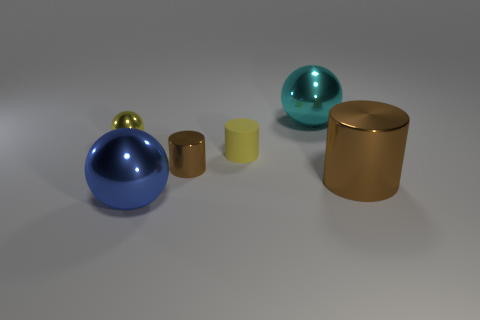Subtract all green blocks. How many brown cylinders are left? 2 Subtract all big shiny balls. How many balls are left? 1 Add 2 small yellow cubes. How many objects exist? 8 Subtract all gray spheres. Subtract all red blocks. How many spheres are left? 3 Add 2 tiny yellow shiny things. How many tiny yellow shiny things are left? 3 Add 3 big purple blocks. How many big purple blocks exist? 3 Subtract 0 gray balls. How many objects are left? 6 Subtract all blue rubber balls. Subtract all large blue objects. How many objects are left? 5 